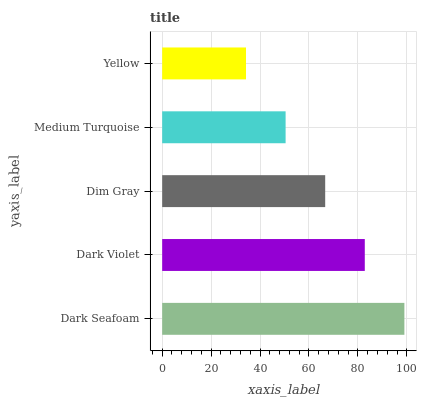Is Yellow the minimum?
Answer yes or no. Yes. Is Dark Seafoam the maximum?
Answer yes or no. Yes. Is Dark Violet the minimum?
Answer yes or no. No. Is Dark Violet the maximum?
Answer yes or no. No. Is Dark Seafoam greater than Dark Violet?
Answer yes or no. Yes. Is Dark Violet less than Dark Seafoam?
Answer yes or no. Yes. Is Dark Violet greater than Dark Seafoam?
Answer yes or no. No. Is Dark Seafoam less than Dark Violet?
Answer yes or no. No. Is Dim Gray the high median?
Answer yes or no. Yes. Is Dim Gray the low median?
Answer yes or no. Yes. Is Dark Violet the high median?
Answer yes or no. No. Is Yellow the low median?
Answer yes or no. No. 